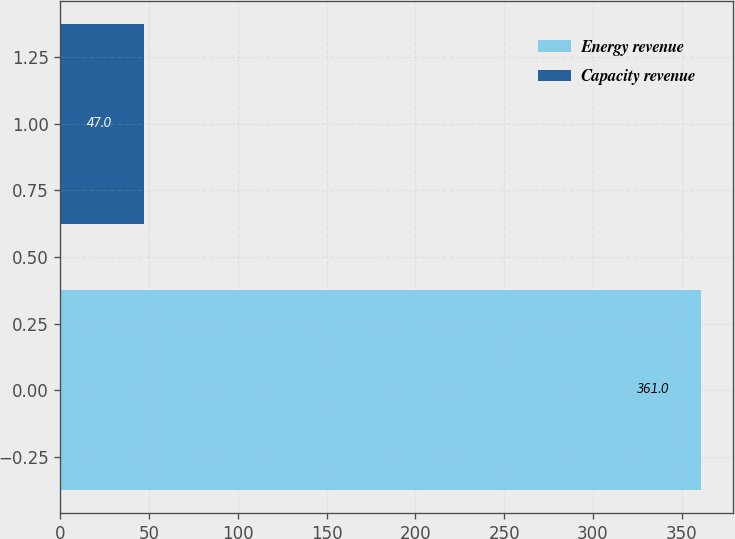Convert chart. <chart><loc_0><loc_0><loc_500><loc_500><bar_chart><fcel>Energy revenue<fcel>Capacity revenue<nl><fcel>361<fcel>47<nl></chart> 